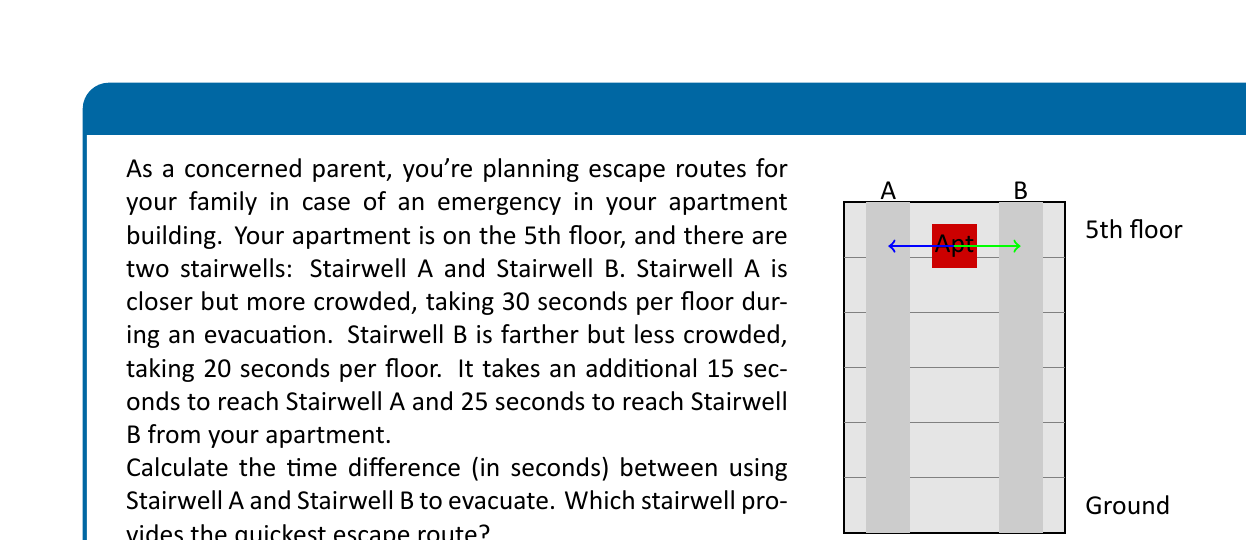Can you answer this question? Let's approach this step-by-step:

1) First, let's calculate the time for Stairwell A:
   - Time to reach Stairwell A: 15 seconds
   - Time to descend 5 floors: $5 \times 30 = 150$ seconds
   - Total time for Stairwell A: $15 + 150 = 165$ seconds

2) Now, let's calculate the time for Stairwell B:
   - Time to reach Stairwell B: 25 seconds
   - Time to descend 5 floors: $5 \times 20 = 100$ seconds
   - Total time for Stairwell B: $25 + 100 = 125$ seconds

3) To find the time difference, we subtract the shorter time from the longer time:
   $165 - 125 = 40$ seconds

4) To determine which stairwell is quicker, we compare the total times:
   Stairwell A: 165 seconds
   Stairwell B: 125 seconds

   Stairwell B is quicker by 40 seconds.

Therefore, Stairwell B provides the quickest escape route, despite being farther from the apartment initially.
Answer: 40 seconds; Stairwell B 